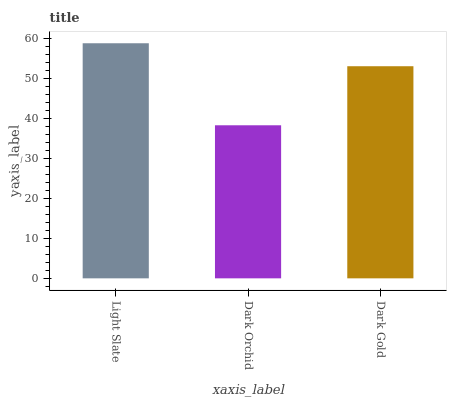Is Dark Orchid the minimum?
Answer yes or no. Yes. Is Light Slate the maximum?
Answer yes or no. Yes. Is Dark Gold the minimum?
Answer yes or no. No. Is Dark Gold the maximum?
Answer yes or no. No. Is Dark Gold greater than Dark Orchid?
Answer yes or no. Yes. Is Dark Orchid less than Dark Gold?
Answer yes or no. Yes. Is Dark Orchid greater than Dark Gold?
Answer yes or no. No. Is Dark Gold less than Dark Orchid?
Answer yes or no. No. Is Dark Gold the high median?
Answer yes or no. Yes. Is Dark Gold the low median?
Answer yes or no. Yes. Is Dark Orchid the high median?
Answer yes or no. No. Is Light Slate the low median?
Answer yes or no. No. 